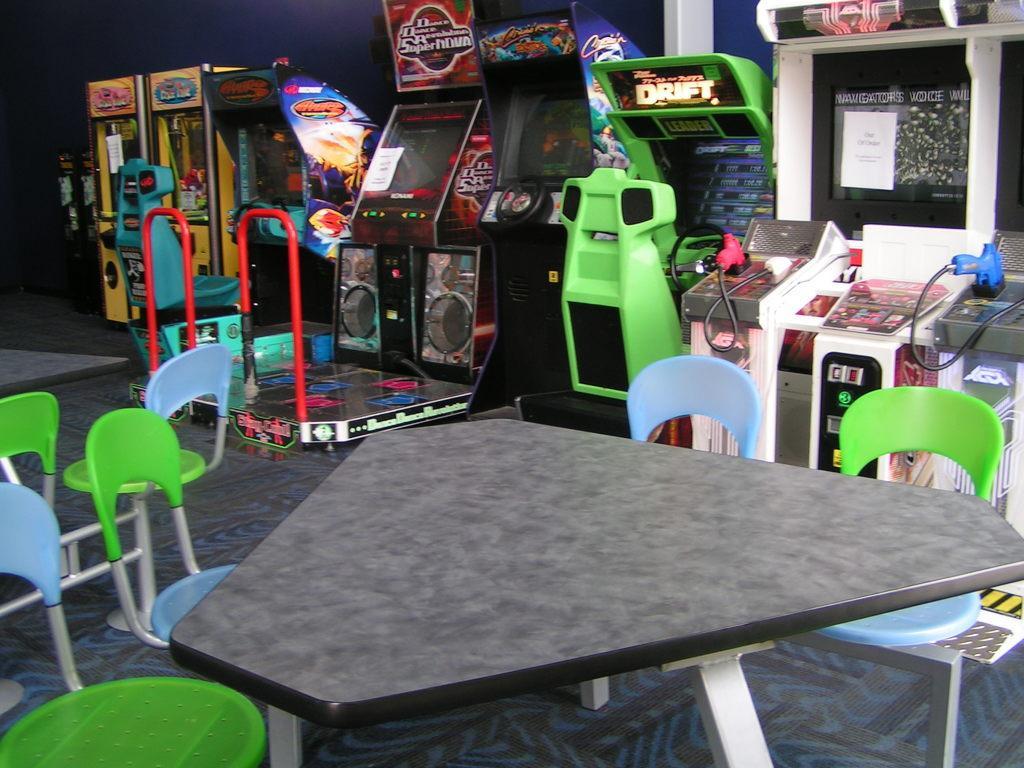Could you give a brief overview of what you see in this image? At the bottom of the image there is a table and we can see chairs. In the background there is a game zone and we can see a wall. 